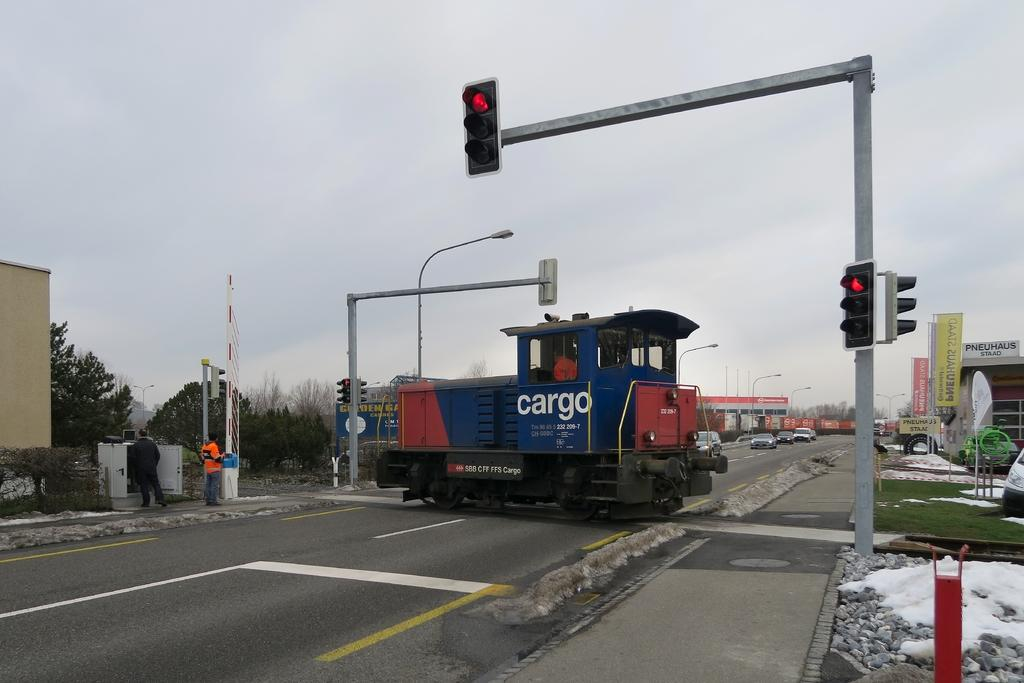<image>
Give a short and clear explanation of the subsequent image. Blue part of a train which says "cargo" on it. 